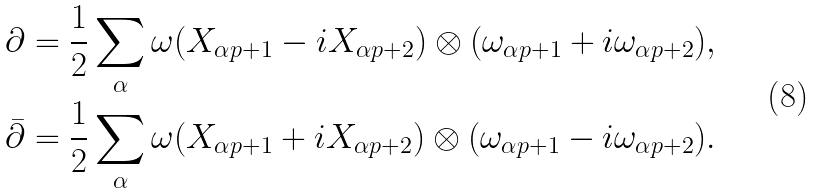Convert formula to latex. <formula><loc_0><loc_0><loc_500><loc_500>\partial = \frac { 1 } { 2 } \sum _ { \alpha } \omega ( X _ { \alpha p + 1 } - i X _ { \alpha p + 2 } ) \otimes ( \omega _ { \alpha p + 1 } + i \omega _ { \alpha p + 2 } ) , \\ \bar { \partial } = \frac { 1 } { 2 } \sum _ { \alpha } \omega ( X _ { \alpha p + 1 } + i X _ { \alpha p + 2 } ) \otimes ( \omega _ { \alpha p + 1 } - i \omega _ { \alpha p + 2 } ) .</formula> 